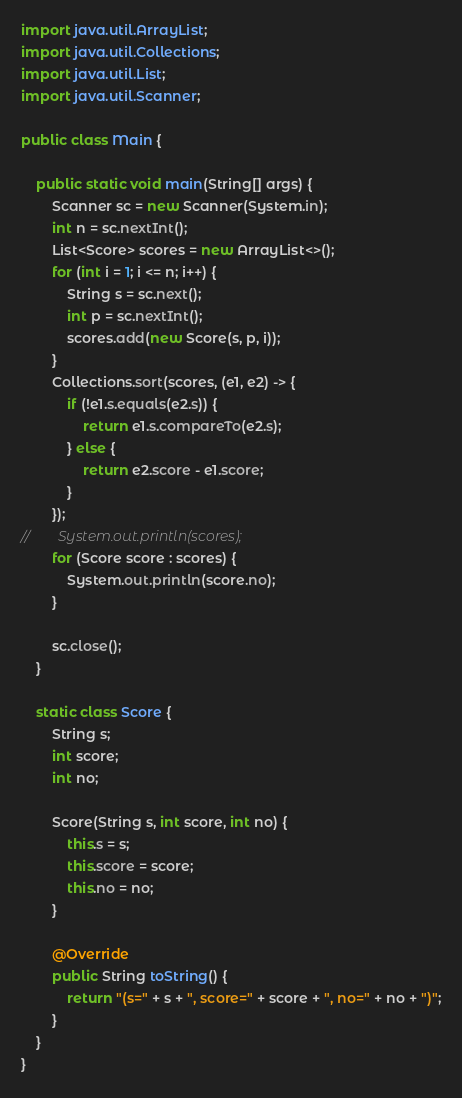<code> <loc_0><loc_0><loc_500><loc_500><_Java_>import java.util.ArrayList;
import java.util.Collections;
import java.util.List;
import java.util.Scanner;

public class Main {

    public static void main(String[] args) {
        Scanner sc = new Scanner(System.in);
        int n = sc.nextInt();
        List<Score> scores = new ArrayList<>();
        for (int i = 1; i <= n; i++) {
            String s = sc.next();
            int p = sc.nextInt();
            scores.add(new Score(s, p, i));
        }
        Collections.sort(scores, (e1, e2) -> {
            if (!e1.s.equals(e2.s)) {
                return e1.s.compareTo(e2.s);
            } else {
                return e2.score - e1.score;
            }
        });
//        System.out.println(scores);
        for (Score score : scores) {
            System.out.println(score.no);
        }

        sc.close();
    }

    static class Score {
        String s;
        int score;
        int no;

        Score(String s, int score, int no) {
            this.s = s;
            this.score = score;
            this.no = no;
        }

        @Override
        public String toString() {
            return "(s=" + s + ", score=" + score + ", no=" + no + ")";
        }
    }
}
</code> 